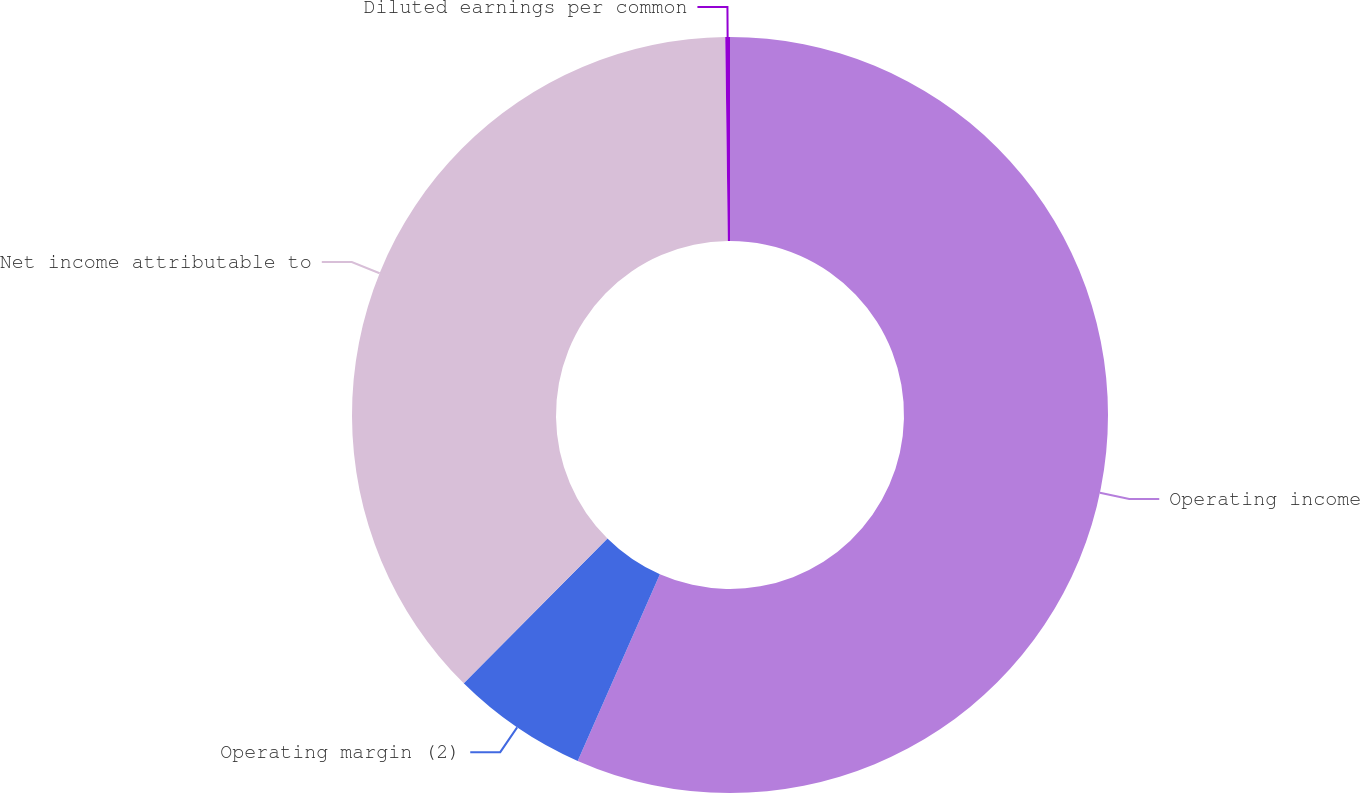Convert chart. <chart><loc_0><loc_0><loc_500><loc_500><pie_chart><fcel>Operating income<fcel>Operating margin (2)<fcel>Net income attributable to<fcel>Diluted earnings per common<nl><fcel>56.6%<fcel>5.84%<fcel>37.36%<fcel>0.2%<nl></chart> 